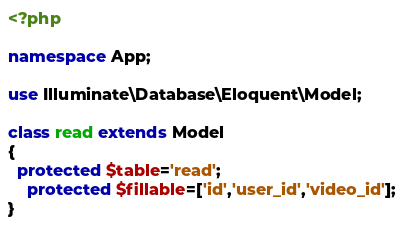Convert code to text. <code><loc_0><loc_0><loc_500><loc_500><_PHP_><?php

namespace App;

use Illuminate\Database\Eloquent\Model;

class read extends Model
{
  protected $table='read';
    protected $fillable=['id','user_id','video_id'];
}
</code> 